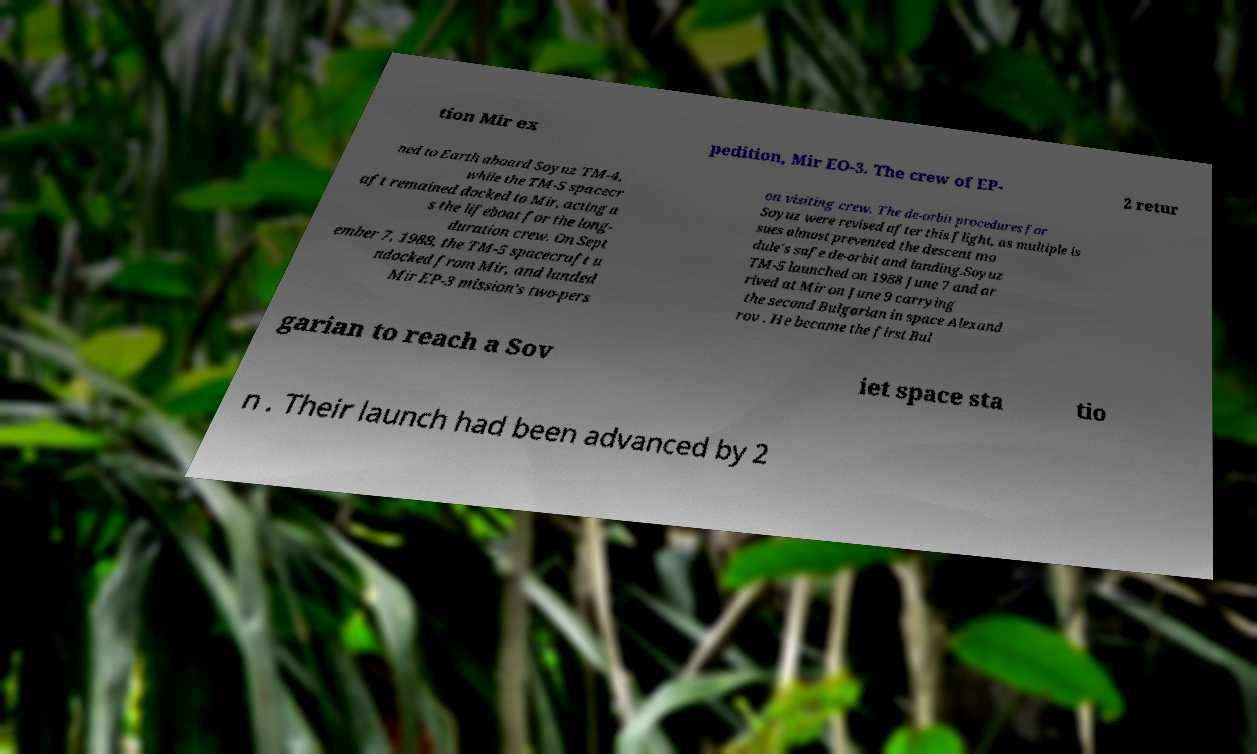Could you assist in decoding the text presented in this image and type it out clearly? tion Mir ex pedition, Mir EO-3. The crew of EP- 2 retur ned to Earth aboard Soyuz TM-4, while the TM-5 spacecr aft remained docked to Mir, acting a s the lifeboat for the long- duration crew. On Sept ember 7, 1988, the TM-5 spacecraft u ndocked from Mir, and landed Mir EP-3 mission's two-pers on visiting crew. The de-orbit procedures for Soyuz were revised after this flight, as multiple is sues almost prevented the descent mo dule's safe de-orbit and landing.Soyuz TM-5 launched on 1988 June 7 and ar rived at Mir on June 9 carrying the second Bulgarian in space Alexand rov . He became the first Bul garian to reach a Sov iet space sta tio n . Their launch had been advanced by 2 